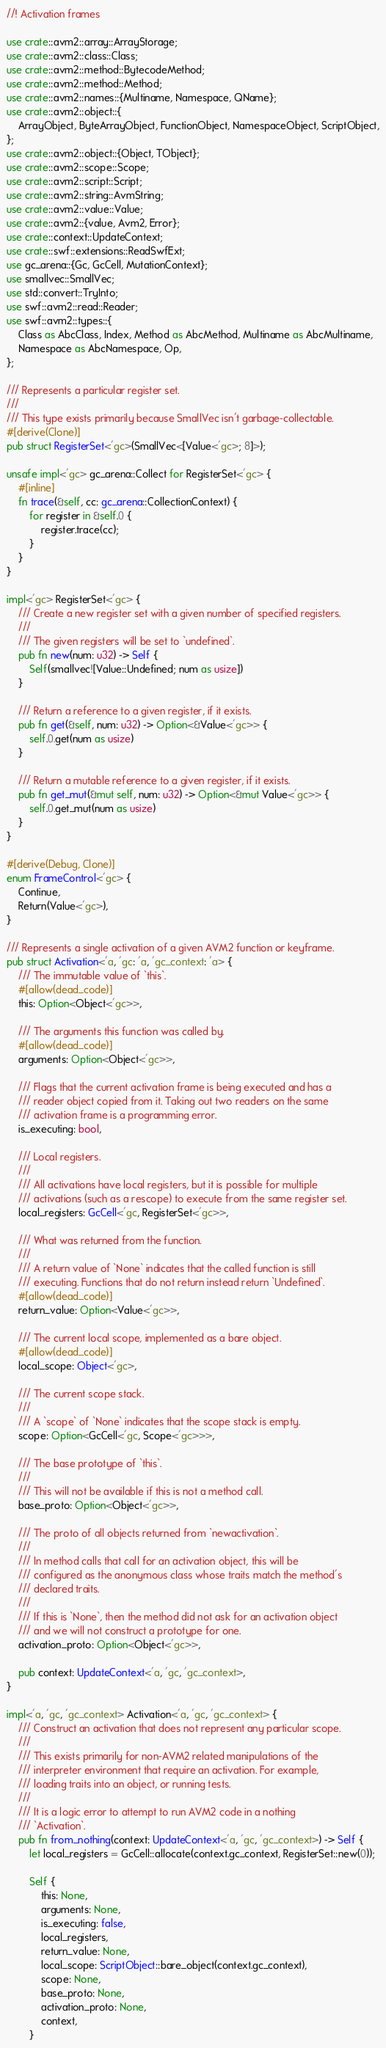<code> <loc_0><loc_0><loc_500><loc_500><_Rust_>//! Activation frames

use crate::avm2::array::ArrayStorage;
use crate::avm2::class::Class;
use crate::avm2::method::BytecodeMethod;
use crate::avm2::method::Method;
use crate::avm2::names::{Multiname, Namespace, QName};
use crate::avm2::object::{
    ArrayObject, ByteArrayObject, FunctionObject, NamespaceObject, ScriptObject,
};
use crate::avm2::object::{Object, TObject};
use crate::avm2::scope::Scope;
use crate::avm2::script::Script;
use crate::avm2::string::AvmString;
use crate::avm2::value::Value;
use crate::avm2::{value, Avm2, Error};
use crate::context::UpdateContext;
use crate::swf::extensions::ReadSwfExt;
use gc_arena::{Gc, GcCell, MutationContext};
use smallvec::SmallVec;
use std::convert::TryInto;
use swf::avm2::read::Reader;
use swf::avm2::types::{
    Class as AbcClass, Index, Method as AbcMethod, Multiname as AbcMultiname,
    Namespace as AbcNamespace, Op,
};

/// Represents a particular register set.
///
/// This type exists primarily because SmallVec isn't garbage-collectable.
#[derive(Clone)]
pub struct RegisterSet<'gc>(SmallVec<[Value<'gc>; 8]>);

unsafe impl<'gc> gc_arena::Collect for RegisterSet<'gc> {
    #[inline]
    fn trace(&self, cc: gc_arena::CollectionContext) {
        for register in &self.0 {
            register.trace(cc);
        }
    }
}

impl<'gc> RegisterSet<'gc> {
    /// Create a new register set with a given number of specified registers.
    ///
    /// The given registers will be set to `undefined`.
    pub fn new(num: u32) -> Self {
        Self(smallvec![Value::Undefined; num as usize])
    }

    /// Return a reference to a given register, if it exists.
    pub fn get(&self, num: u32) -> Option<&Value<'gc>> {
        self.0.get(num as usize)
    }

    /// Return a mutable reference to a given register, if it exists.
    pub fn get_mut(&mut self, num: u32) -> Option<&mut Value<'gc>> {
        self.0.get_mut(num as usize)
    }
}

#[derive(Debug, Clone)]
enum FrameControl<'gc> {
    Continue,
    Return(Value<'gc>),
}

/// Represents a single activation of a given AVM2 function or keyframe.
pub struct Activation<'a, 'gc: 'a, 'gc_context: 'a> {
    /// The immutable value of `this`.
    #[allow(dead_code)]
    this: Option<Object<'gc>>,

    /// The arguments this function was called by.
    #[allow(dead_code)]
    arguments: Option<Object<'gc>>,

    /// Flags that the current activation frame is being executed and has a
    /// reader object copied from it. Taking out two readers on the same
    /// activation frame is a programming error.
    is_executing: bool,

    /// Local registers.
    ///
    /// All activations have local registers, but it is possible for multiple
    /// activations (such as a rescope) to execute from the same register set.
    local_registers: GcCell<'gc, RegisterSet<'gc>>,

    /// What was returned from the function.
    ///
    /// A return value of `None` indicates that the called function is still
    /// executing. Functions that do not return instead return `Undefined`.
    #[allow(dead_code)]
    return_value: Option<Value<'gc>>,

    /// The current local scope, implemented as a bare object.
    #[allow(dead_code)]
    local_scope: Object<'gc>,

    /// The current scope stack.
    ///
    /// A `scope` of `None` indicates that the scope stack is empty.
    scope: Option<GcCell<'gc, Scope<'gc>>>,

    /// The base prototype of `this`.
    ///
    /// This will not be available if this is not a method call.
    base_proto: Option<Object<'gc>>,

    /// The proto of all objects returned from `newactivation`.
    ///
    /// In method calls that call for an activation object, this will be
    /// configured as the anonymous class whose traits match the method's
    /// declared traits.
    ///
    /// If this is `None`, then the method did not ask for an activation object
    /// and we will not construct a prototype for one.
    activation_proto: Option<Object<'gc>>,

    pub context: UpdateContext<'a, 'gc, 'gc_context>,
}

impl<'a, 'gc, 'gc_context> Activation<'a, 'gc, 'gc_context> {
    /// Construct an activation that does not represent any particular scope.
    ///
    /// This exists primarily for non-AVM2 related manipulations of the
    /// interpreter environment that require an activation. For example,
    /// loading traits into an object, or running tests.
    ///
    /// It is a logic error to attempt to run AVM2 code in a nothing
    /// `Activation`.
    pub fn from_nothing(context: UpdateContext<'a, 'gc, 'gc_context>) -> Self {
        let local_registers = GcCell::allocate(context.gc_context, RegisterSet::new(0));

        Self {
            this: None,
            arguments: None,
            is_executing: false,
            local_registers,
            return_value: None,
            local_scope: ScriptObject::bare_object(context.gc_context),
            scope: None,
            base_proto: None,
            activation_proto: None,
            context,
        }</code> 